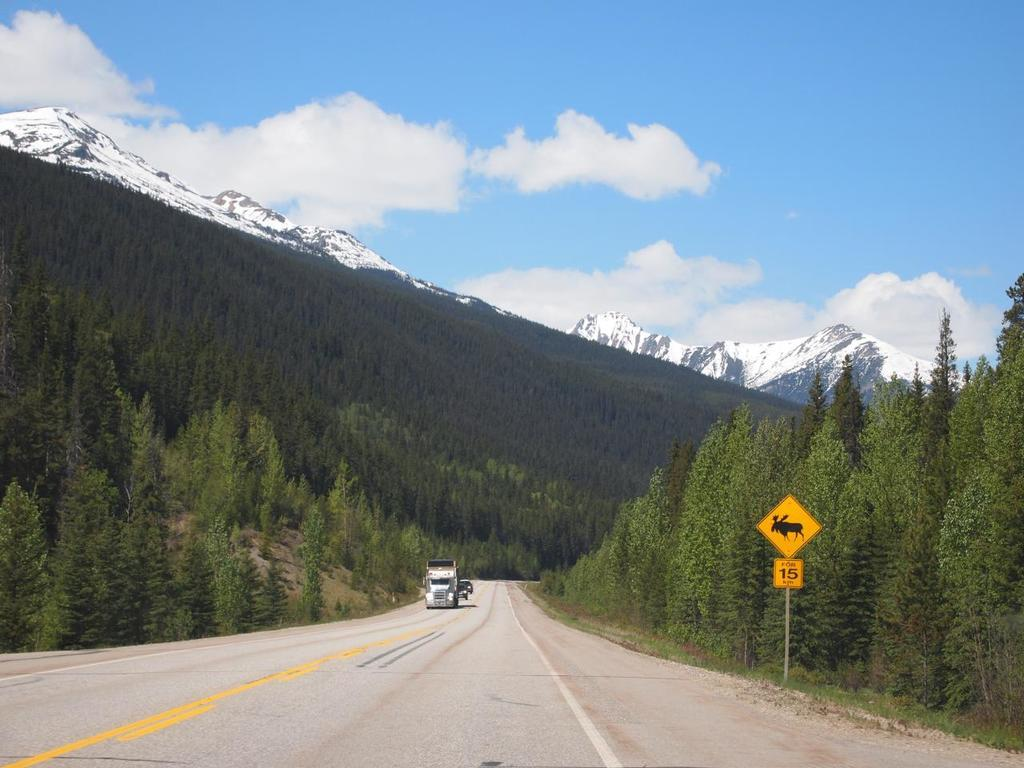What type of vegetation can be seen in the image? There are trees and grass in the image. What is attached to the pole in the image? There are sign boards on the pole in the image. What type of terrain is visible in the image? There are hills in the image. What is moving along the road at the bottom of the image? There are vehicles on the road at the bottom of the image. What is the condition of the sky in the image? The sky is cloudy in the background of the image. How many eyes can be seen on the trees in the image? Trees do not have eyes, so there are no eyes visible on the trees in the image. Who is the friend standing next to the pole in the image? There is no person or friend present in the image; only trees, grass, a pole with sign boards, hills, vehicles on the road, and a cloudy sky are visible. 